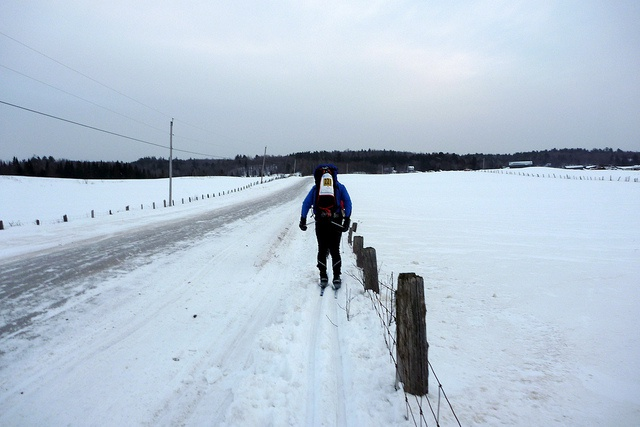Describe the objects in this image and their specific colors. I can see people in lightblue, black, navy, gray, and darkblue tones, backpack in lightblue, black, maroon, and lightgray tones, and skis in lightblue, gray, blue, darkgray, and black tones in this image. 